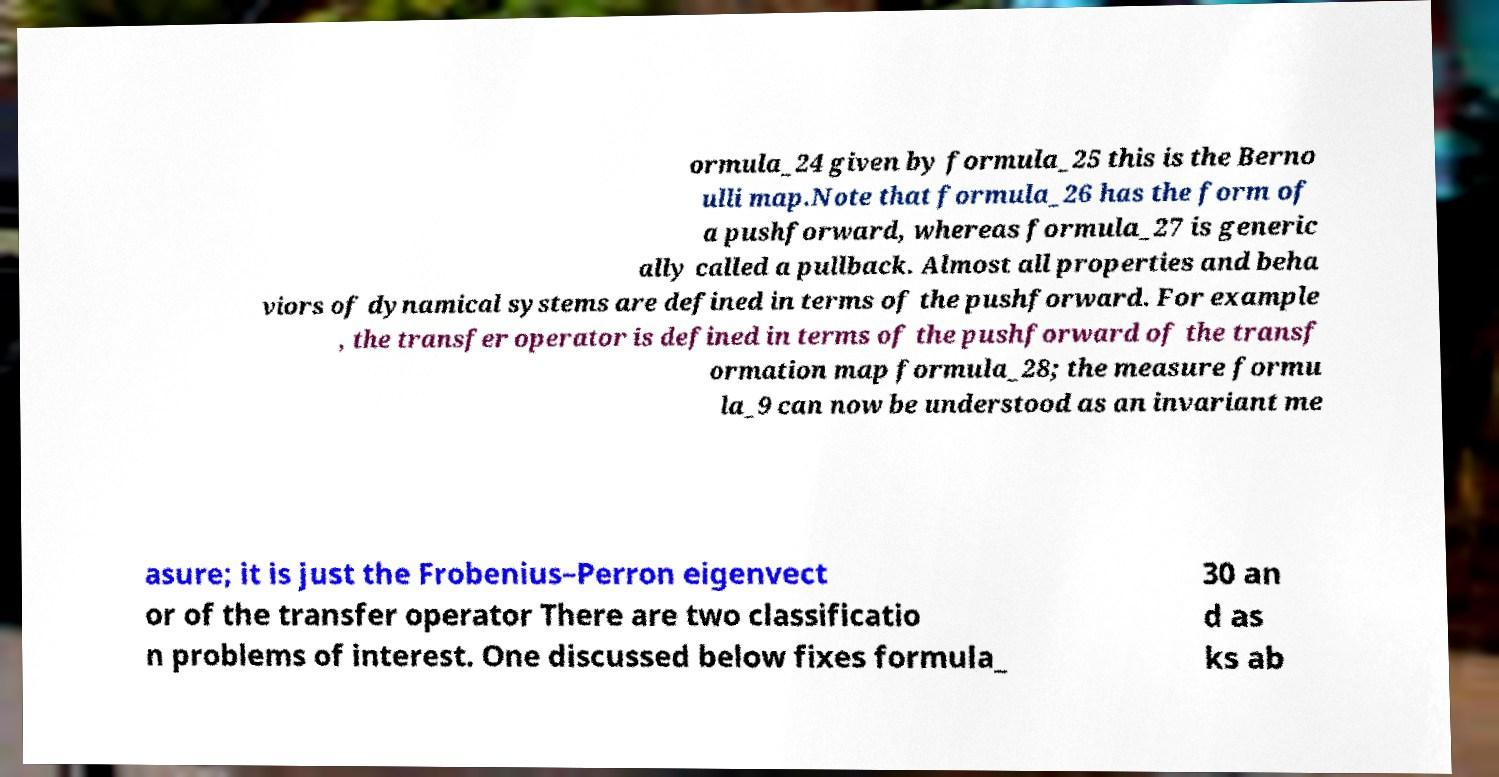Could you assist in decoding the text presented in this image and type it out clearly? ormula_24 given by formula_25 this is the Berno ulli map.Note that formula_26 has the form of a pushforward, whereas formula_27 is generic ally called a pullback. Almost all properties and beha viors of dynamical systems are defined in terms of the pushforward. For example , the transfer operator is defined in terms of the pushforward of the transf ormation map formula_28; the measure formu la_9 can now be understood as an invariant me asure; it is just the Frobenius–Perron eigenvect or of the transfer operator There are two classificatio n problems of interest. One discussed below fixes formula_ 30 an d as ks ab 